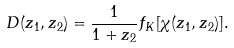<formula> <loc_0><loc_0><loc_500><loc_500>D ( z _ { 1 } , z _ { 2 } ) = \frac { 1 } { 1 + z _ { 2 } } f _ { K } [ \chi ( z _ { 1 } , z _ { 2 } ) ] .</formula> 